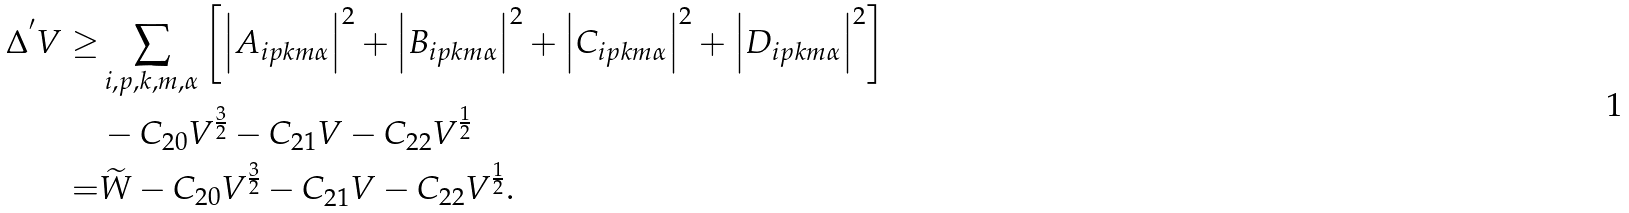<formula> <loc_0><loc_0><loc_500><loc_500>\Delta ^ { ^ { \prime } } V \geq & \sum _ { i , p , k , m , \alpha } \left [ \left | A _ { i p k m \alpha } \right | ^ { 2 } + \left | B _ { i p k m \alpha } \right | ^ { 2 } + \left | C _ { i p k m \alpha } \right | ^ { 2 } + \left | D _ { i p k m \alpha } \right | ^ { 2 } \right ] \\ & - C _ { 2 0 } V ^ { \frac { 3 } { 2 } } - C _ { 2 1 } V - C _ { 2 2 } V ^ { \frac { 1 } { 2 } } \\ = & \widetilde { W } - C _ { 2 0 } V ^ { \frac { 3 } { 2 } } - C _ { 2 1 } V - C _ { 2 2 } V ^ { \frac { 1 } { 2 } } .</formula> 